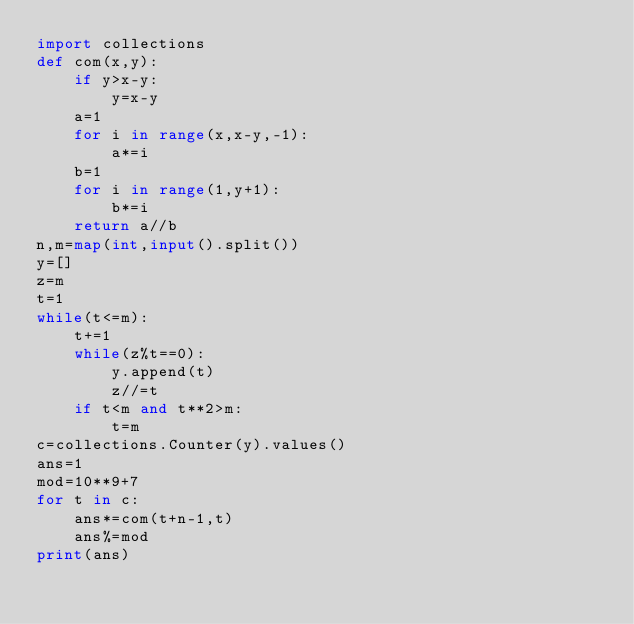Convert code to text. <code><loc_0><loc_0><loc_500><loc_500><_Python_>import collections
def com(x,y):
    if y>x-y:
        y=x-y
    a=1
    for i in range(x,x-y,-1):
        a*=i
    b=1
    for i in range(1,y+1):
        b*=i
    return a//b
n,m=map(int,input().split())
y=[]
z=m
t=1
while(t<=m):
    t+=1
    while(z%t==0):
        y.append(t)
        z//=t
    if t<m and t**2>m:
        t=m
c=collections.Counter(y).values()
ans=1
mod=10**9+7
for t in c:
    ans*=com(t+n-1,t)
    ans%=mod
print(ans)</code> 